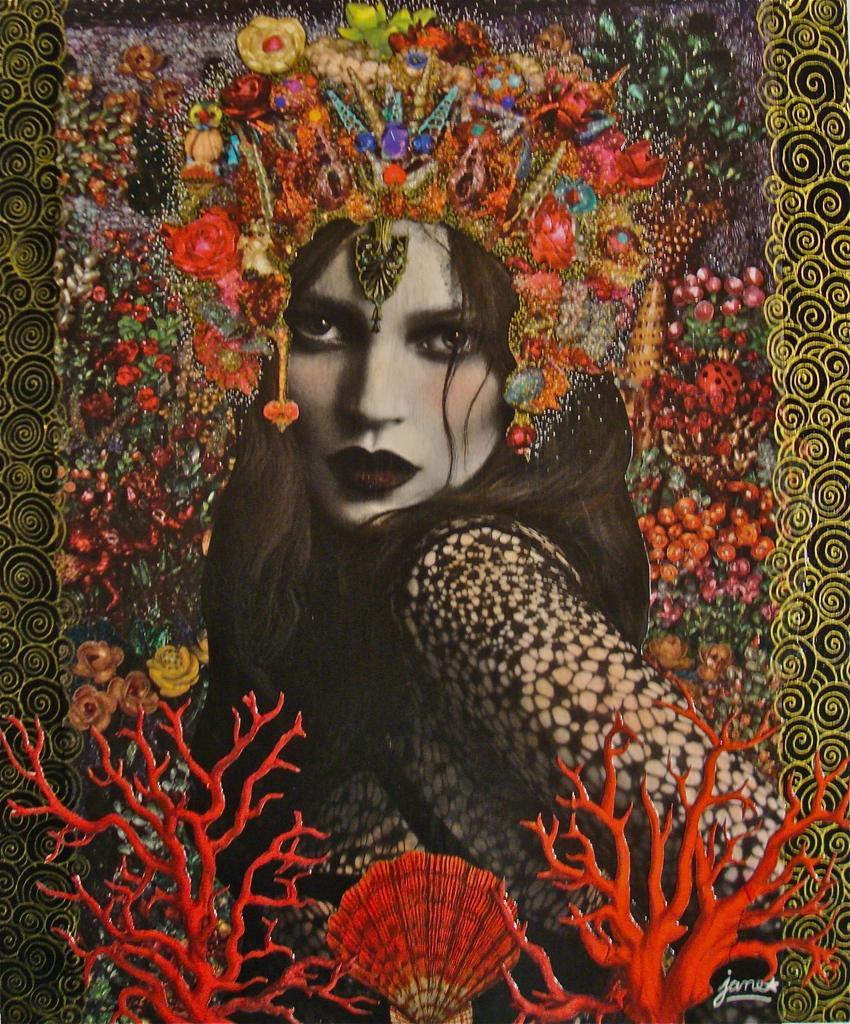Please provide a concise description of this image. It is an edited image. In this image at the center there is a woman wearing the crown. 